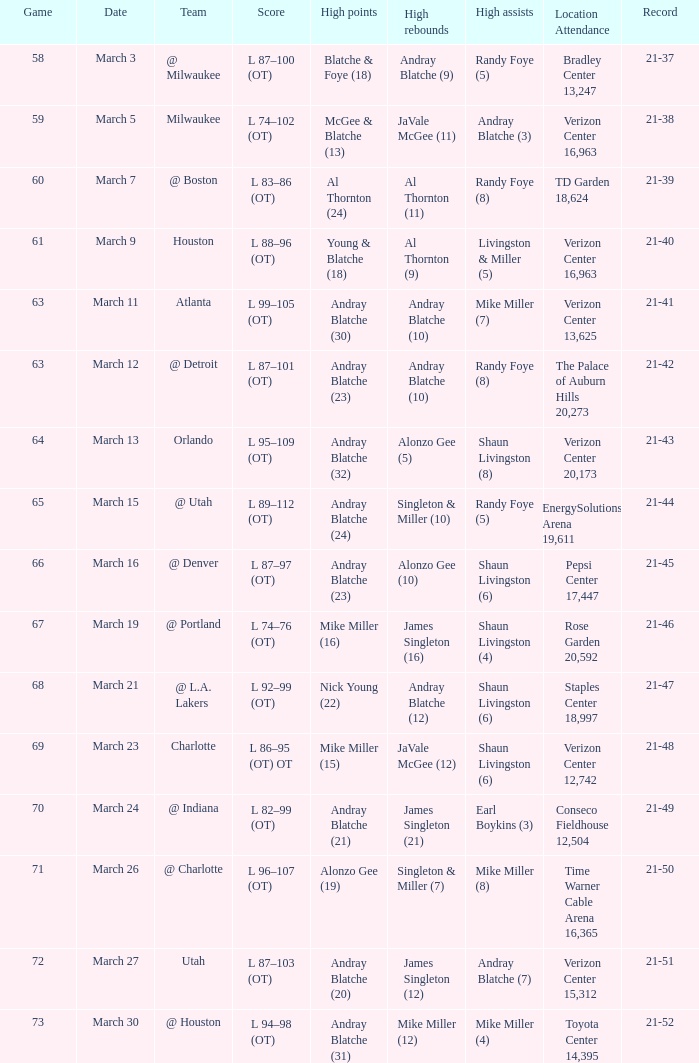On which date was the attendance at td garden 18,624? March 7. 